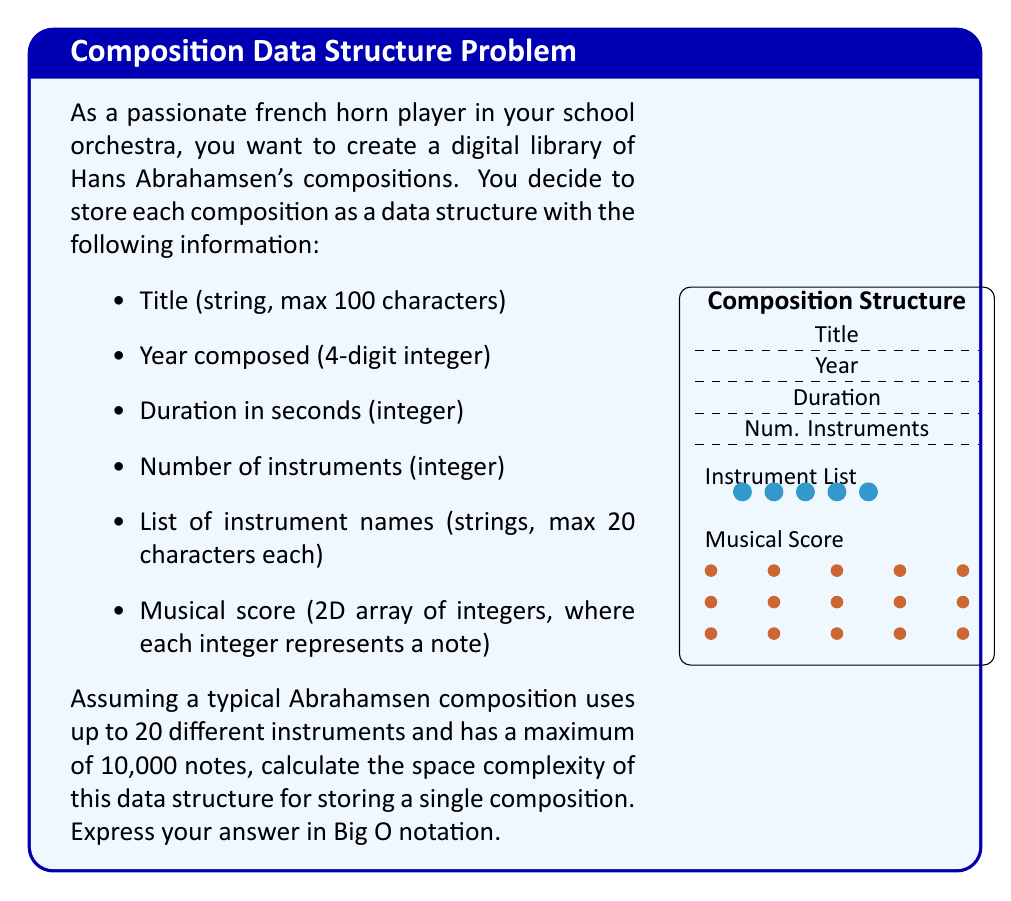Solve this math problem. Let's break down the space complexity analysis step by step:

1. Title: 
   - Max 100 characters
   - Space: $O(100)$ or $O(1)$ since it's constant

2. Year composed: 
   - 4-digit integer
   - Space: $O(1)$

3. Duration in seconds: 
   - Integer
   - Space: $O(1)$

4. Number of instruments: 
   - Integer
   - Space: $O(1)$

5. List of instrument names:
   - Up to 20 instruments, each name max 20 characters
   - Space: $O(20 \times 20) = O(400)$ or $O(1)$ since it's constant

6. Musical score:
   - 2D array of integers
   - Maximum 10,000 notes
   - Space: $O(10000)$ or $O(n)$ where $n$ is the number of notes

Now, let's combine these:

$$ O(1) + O(1) + O(1) + O(1) + O(1) + O(n) $$

In Big O notation, we only consider the highest order term, which in this case is $O(n)$.

Therefore, the overall space complexity for storing a single composition is $O(n)$, where $n$ represents the number of notes in the composition.

Note: Even though we have a maximum of 10,000 notes, we use $O(n)$ instead of $O(10000)$ or $O(1)$ because:
1. The actual number of notes can vary between compositions.
2. It's generally more useful to express complexity in terms of input size.
3. If we later decide to allow for longer compositions, the $O(n)$ notation will still be accurate.
Answer: $O(n)$, where $n$ is the number of notes in the composition 